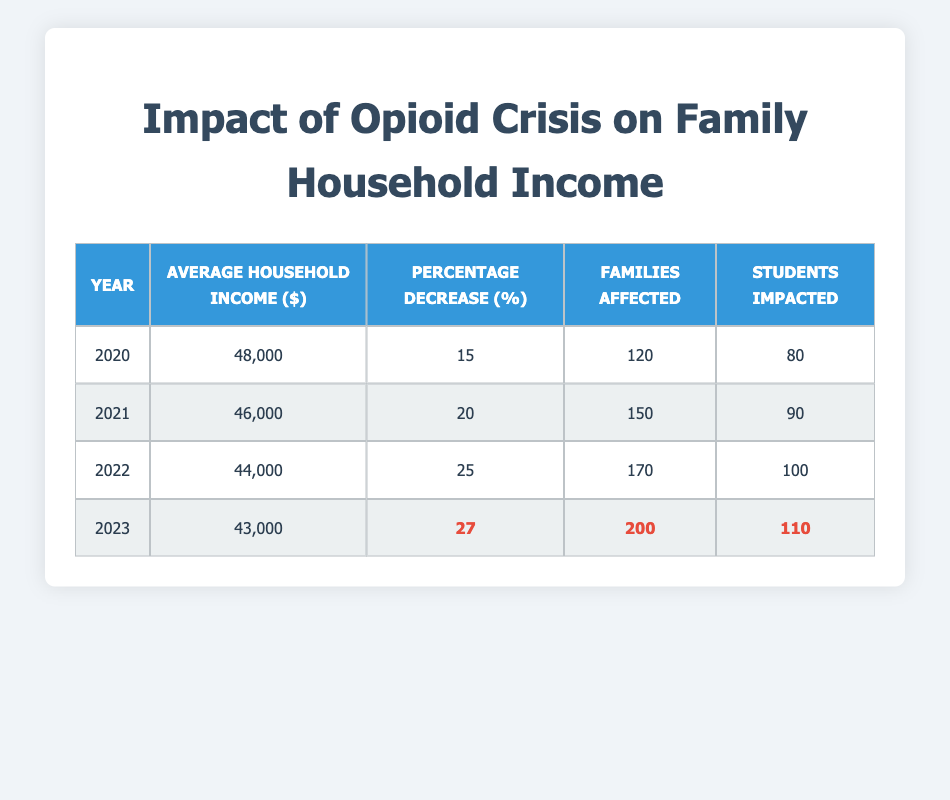What was the average household income in 2021? According to the table, the average household income for the year 2021 is listed in that specific row as 46000.
Answer: 46000 How many families were affected by the opioid crisis in 2023? The table clearly indicates that the number of families affected in 2023 is 200, as shown in the relevant row.
Answer: 200 What is the percentage decrease in average household income from 2020 to 2022? First, find the average household income for 2020 (48000) and for 2022 (44000). Then calculate the decrease: 48000 - 44000 = 4000. To find the percentage decrease, use the formula: (decrease/original) * 100, which gives (4000/48000) * 100 = 8.33.
Answer: 8.33 Did the number of families affected by the opioid crisis increase from 2020 to 2021? Comparing the data, in 2020 there were 120 families affected and in 2021 there were 150. Since 150 is greater than 120, the number increased.
Answer: Yes What is the average household income decrease percentage across all years from 2020 to 2023? We can find the average percentage decrease by taking the sum of the percentage decreases (15 + 20 + 25 + 27 = 87) and dividing by the number of years (4). Thus, the average percentage decrease is 87/4 = 21.75.
Answer: 21.75 How many students were impacted in 2022? The table specifies that in the year 2022, the number of students impacted was 100, as shown in that year's row.
Answer: 100 What is the difference in average household income between 2020 and 2023? The average household income for 2020 is 48000 and for 2023 is 43000. To find the difference, subtract 43000 from 48000, giving 48000 - 43000 = 5000.
Answer: 5000 In which year was the highest percentage decrease recorded? By looking at the percentage decrease column, the highest value is 27, which is recorded for the year 2023, making it the year with the most significant decrease.
Answer: 2023 